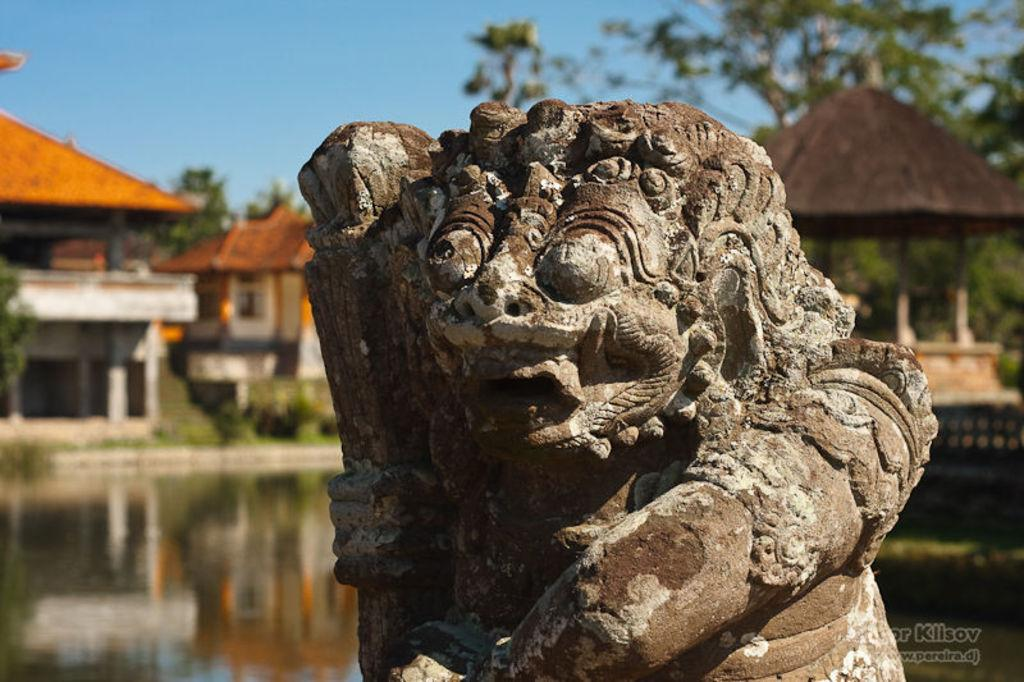What is the main subject in the image? There is a sculpture in the image. What can be seen in the background of the image? There are houses, a hut, trees, and water visible in the background of the image. Can you describe the text visible in the image? Unfortunately, the content of the text cannot be determined from the image alone. What type of natural environment is visible in the image? The image features a combination of natural elements, including trees and water. How many crackers are being held by the arm in the image? There is no arm or crackers present in the image. What type of ticket can be seen in the image? There is no ticket present in the image. 